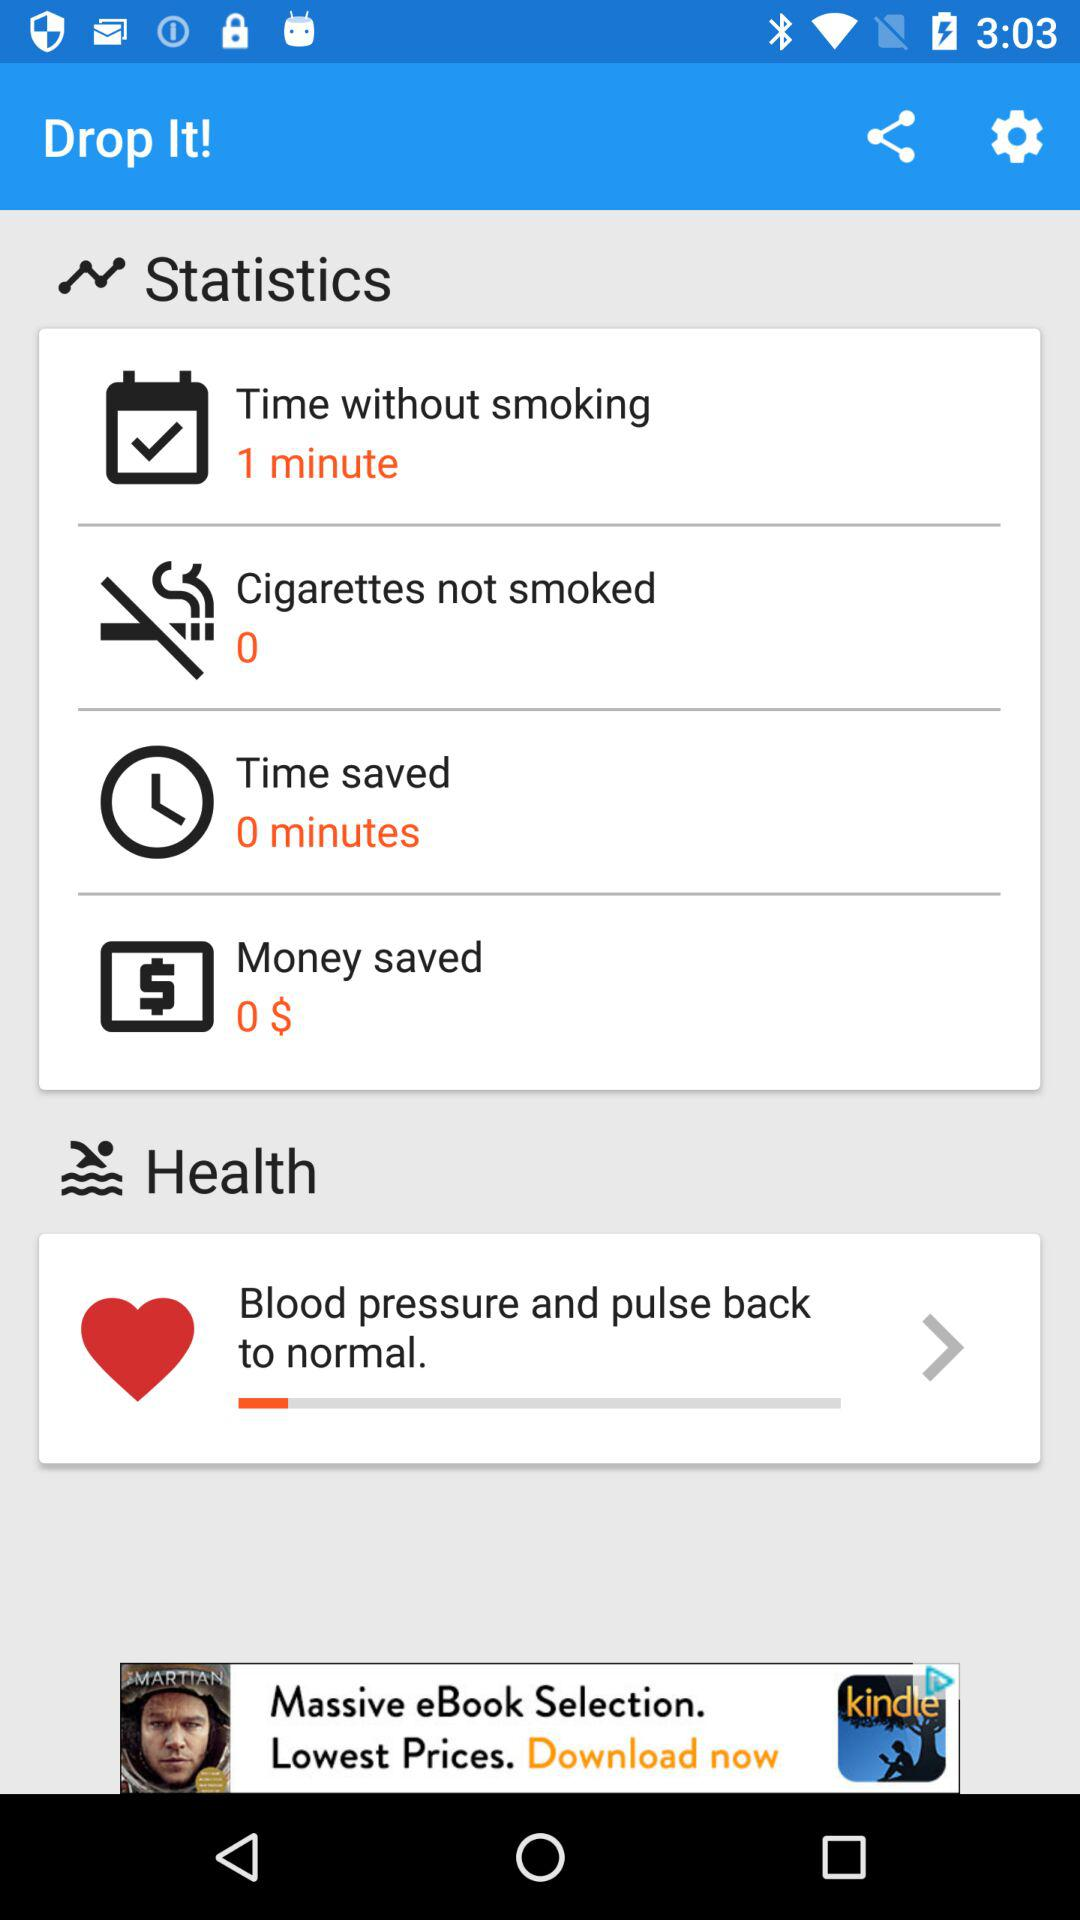How much money has been saved in total?
Answer the question using a single word or phrase. 0 $ 